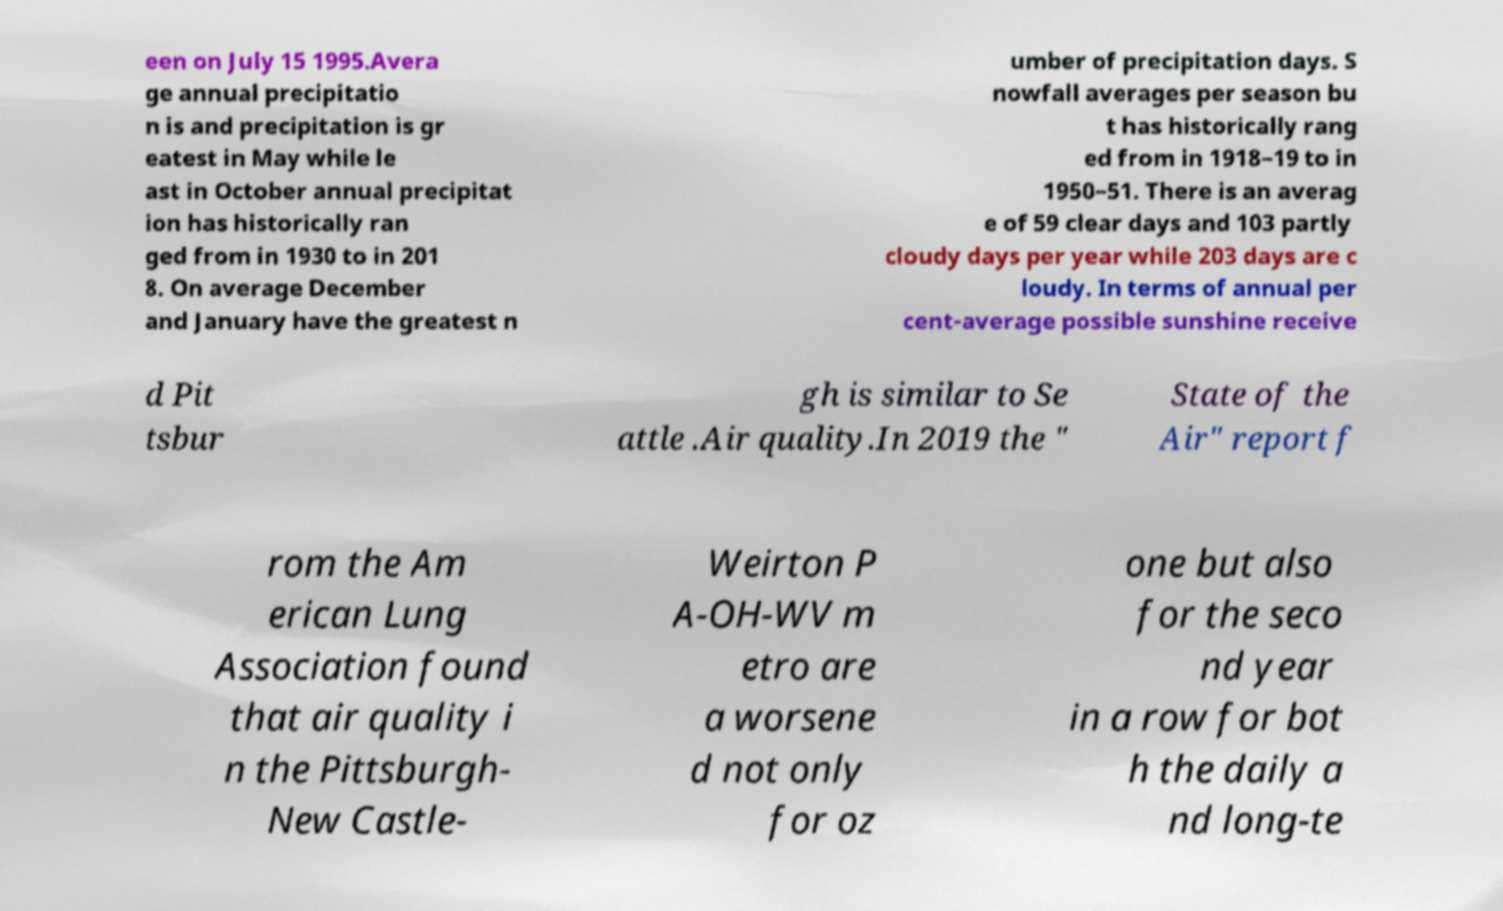There's text embedded in this image that I need extracted. Can you transcribe it verbatim? een on July 15 1995.Avera ge annual precipitatio n is and precipitation is gr eatest in May while le ast in October annual precipitat ion has historically ran ged from in 1930 to in 201 8. On average December and January have the greatest n umber of precipitation days. S nowfall averages per season bu t has historically rang ed from in 1918–19 to in 1950–51. There is an averag e of 59 clear days and 103 partly cloudy days per year while 203 days are c loudy. In terms of annual per cent-average possible sunshine receive d Pit tsbur gh is similar to Se attle .Air quality.In 2019 the " State of the Air" report f rom the Am erican Lung Association found that air quality i n the Pittsburgh- New Castle- Weirton P A-OH-WV m etro are a worsene d not only for oz one but also for the seco nd year in a row for bot h the daily a nd long-te 